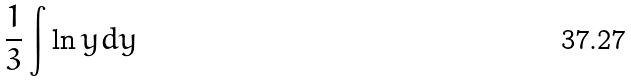Convert formula to latex. <formula><loc_0><loc_0><loc_500><loc_500>\frac { 1 } { 3 } \int \ln y d y</formula> 